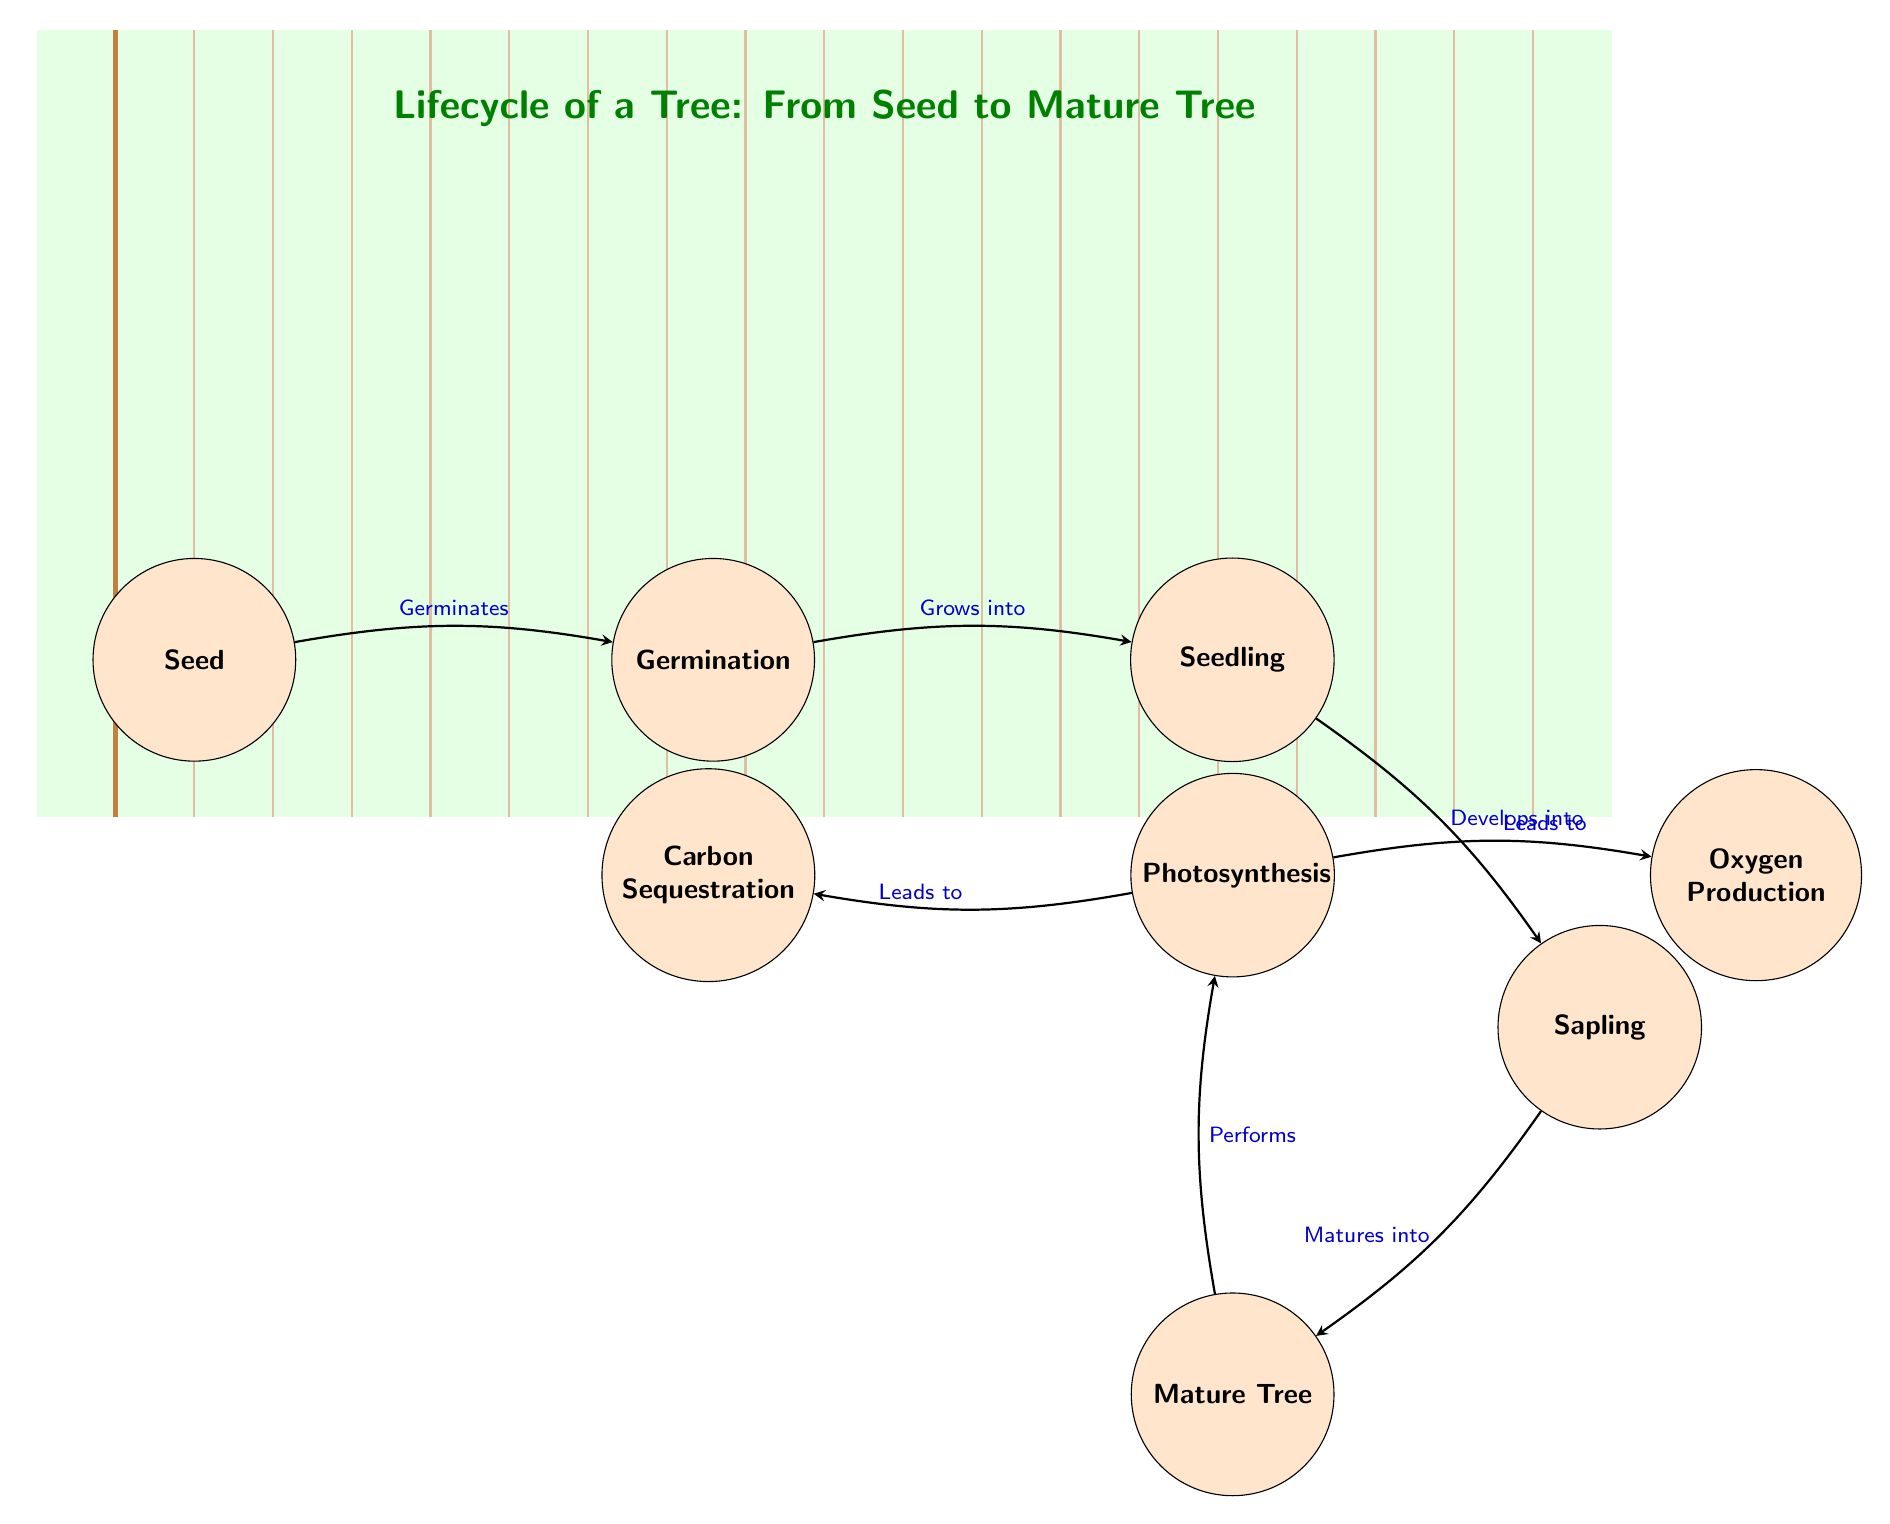What are the stages of growth listed in the diagram? The diagram depicts the stages sequentially: Seed, Germination, Seedling, Sapling, and Mature Tree. These stages represent the growth lifecycle of a tree.
Answer: Seed, Germination, Seedling, Sapling, Mature Tree What is the process that occurs in the mature tree? The mature tree performs the process of photosynthesis, which is explicitly stated in the diagram as the activity associated with the mature tree.
Answer: Photosynthesis How many total nodes are there in the diagram? Counting the distinct stages and processes indicated as nodes, we have Seed, Germination, Seedling, Sapling, Mature Tree, Photosynthesis, Carbon Sequestration, and Oxygen Production, totaling 8 nodes.
Answer: 8 What does the sapling develop into? According to the diagram, the sapling matures into a mature tree, showing the direct transition from one stage to the next.
Answer: Mature Tree What are the two outputs from photosynthesis? The diagram illustrates that the outputs from photosynthesis are Carbon Sequestration and Oxygen Production, indicating the benefits produced in that process.
Answer: Carbon Sequestration, Oxygen Production What is the role of carbon sequestration in the lifecycle? The diagram indicates that carbon sequestration is a result of the process of photosynthesis that occurs in a mature tree, signifying its importance in reducing atmospheric carbon.
Answer: Reducing atmospheric carbon Which stage follows germination in the tree lifecycle? After germination, the next stage according to the diagram is the seedling, which represents an early growth phase.
Answer: Seedling What leads to oxygen production in the diagram? The diagram shows that oxygen production is a result of photosynthesis, linking the two processes in the tree's lifecycle and physiological function.
Answer: Photosynthesis 